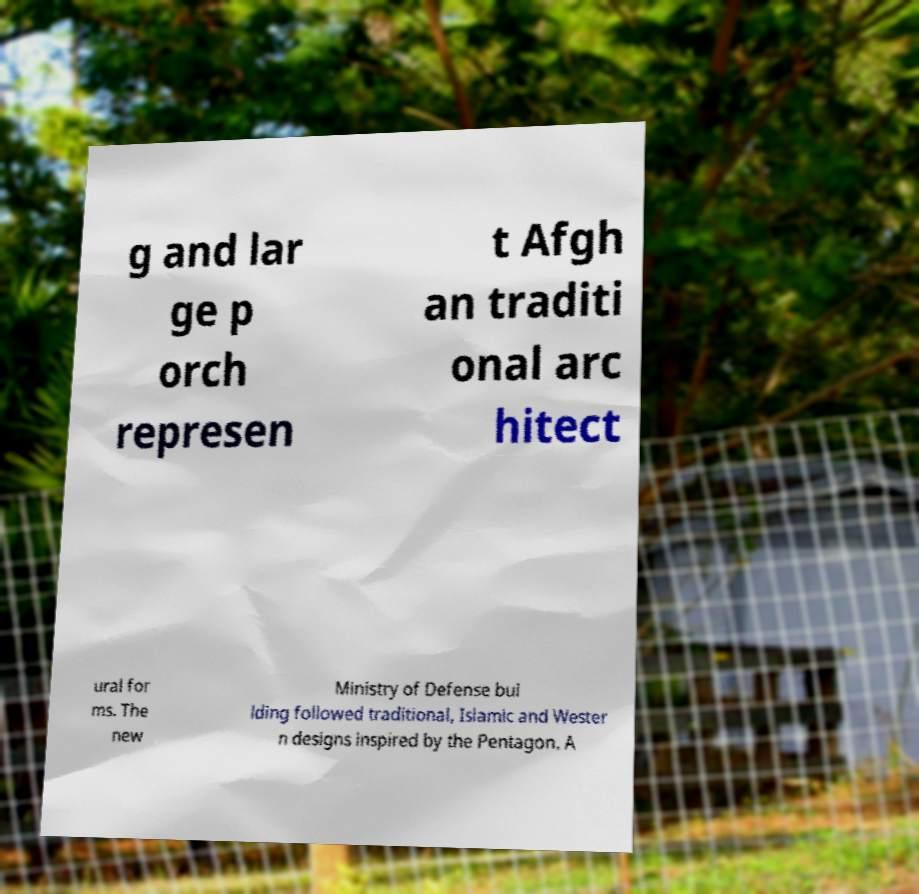Could you extract and type out the text from this image? g and lar ge p orch represen t Afgh an traditi onal arc hitect ural for ms. The new Ministry of Defense bui lding followed traditional, Islamic and Wester n designs inspired by the Pentagon. A 